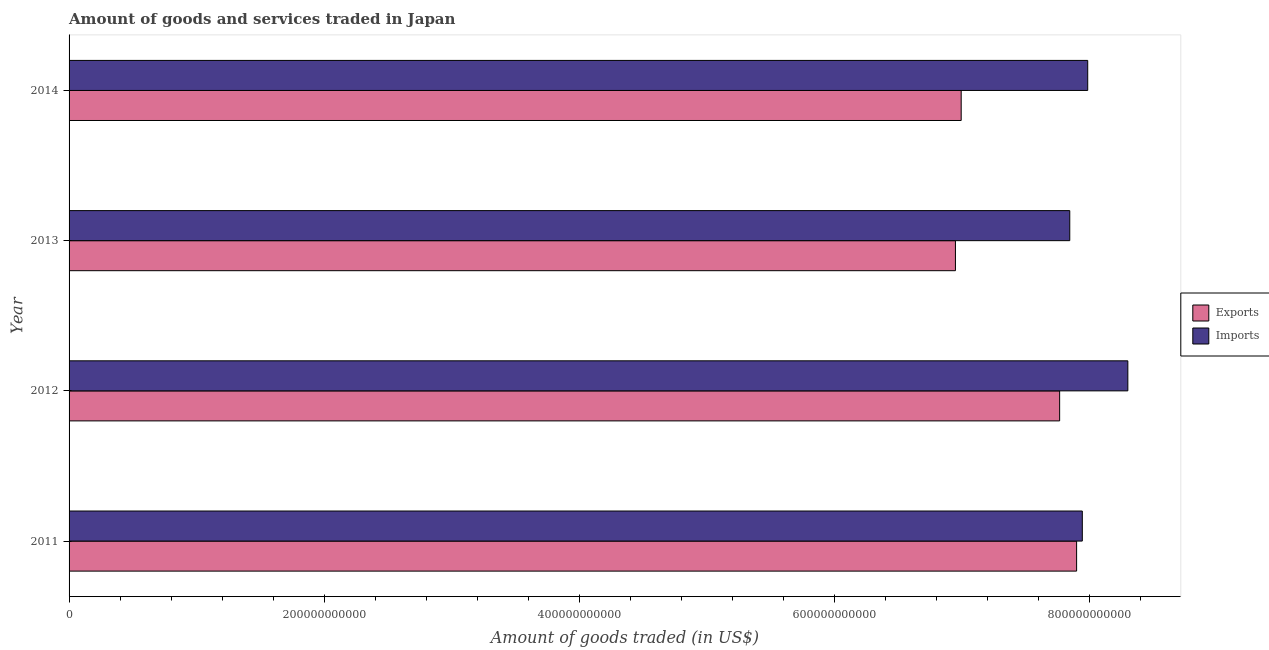How many different coloured bars are there?
Your answer should be compact. 2. How many groups of bars are there?
Offer a terse response. 4. Are the number of bars per tick equal to the number of legend labels?
Provide a short and direct response. Yes. How many bars are there on the 3rd tick from the top?
Make the answer very short. 2. How many bars are there on the 4th tick from the bottom?
Your answer should be very brief. 2. What is the label of the 4th group of bars from the top?
Keep it short and to the point. 2011. What is the amount of goods imported in 2012?
Offer a terse response. 8.30e+11. Across all years, what is the maximum amount of goods exported?
Your response must be concise. 7.90e+11. Across all years, what is the minimum amount of goods exported?
Your answer should be very brief. 6.95e+11. In which year was the amount of goods exported maximum?
Give a very brief answer. 2011. What is the total amount of goods imported in the graph?
Your answer should be very brief. 3.21e+12. What is the difference between the amount of goods exported in 2011 and that in 2013?
Your answer should be compact. 9.50e+1. What is the difference between the amount of goods imported in 2014 and the amount of goods exported in 2011?
Offer a very short reply. 8.70e+09. What is the average amount of goods imported per year?
Offer a terse response. 8.02e+11. In the year 2011, what is the difference between the amount of goods imported and amount of goods exported?
Give a very brief answer. 4.47e+09. What is the ratio of the amount of goods exported in 2011 to that in 2014?
Your response must be concise. 1.13. What is the difference between the highest and the second highest amount of goods imported?
Keep it short and to the point. 3.15e+1. What is the difference between the highest and the lowest amount of goods imported?
Your answer should be compact. 4.55e+1. What does the 2nd bar from the top in 2013 represents?
Your response must be concise. Exports. What does the 2nd bar from the bottom in 2013 represents?
Provide a succinct answer. Imports. Are all the bars in the graph horizontal?
Make the answer very short. Yes. What is the difference between two consecutive major ticks on the X-axis?
Make the answer very short. 2.00e+11. Does the graph contain any zero values?
Keep it short and to the point. No. How are the legend labels stacked?
Your answer should be compact. Vertical. What is the title of the graph?
Provide a short and direct response. Amount of goods and services traded in Japan. What is the label or title of the X-axis?
Provide a short and direct response. Amount of goods traded (in US$). What is the Amount of goods traded (in US$) of Exports in 2011?
Make the answer very short. 7.90e+11. What is the Amount of goods traded (in US$) in Imports in 2011?
Provide a short and direct response. 7.94e+11. What is the Amount of goods traded (in US$) of Exports in 2012?
Your answer should be compact. 7.77e+11. What is the Amount of goods traded (in US$) of Imports in 2012?
Your answer should be compact. 8.30e+11. What is the Amount of goods traded (in US$) in Exports in 2013?
Your response must be concise. 6.95e+11. What is the Amount of goods traded (in US$) of Imports in 2013?
Provide a short and direct response. 7.85e+11. What is the Amount of goods traded (in US$) in Exports in 2014?
Give a very brief answer. 6.99e+11. What is the Amount of goods traded (in US$) of Imports in 2014?
Give a very brief answer. 7.99e+11. Across all years, what is the maximum Amount of goods traded (in US$) of Exports?
Offer a very short reply. 7.90e+11. Across all years, what is the maximum Amount of goods traded (in US$) in Imports?
Provide a short and direct response. 8.30e+11. Across all years, what is the minimum Amount of goods traded (in US$) of Exports?
Your response must be concise. 6.95e+11. Across all years, what is the minimum Amount of goods traded (in US$) of Imports?
Offer a very short reply. 7.85e+11. What is the total Amount of goods traded (in US$) in Exports in the graph?
Provide a succinct answer. 2.96e+12. What is the total Amount of goods traded (in US$) of Imports in the graph?
Provide a short and direct response. 3.21e+12. What is the difference between the Amount of goods traded (in US$) in Exports in 2011 and that in 2012?
Your answer should be very brief. 1.33e+1. What is the difference between the Amount of goods traded (in US$) in Imports in 2011 and that in 2012?
Ensure brevity in your answer.  -3.57e+1. What is the difference between the Amount of goods traded (in US$) in Exports in 2011 and that in 2013?
Your answer should be very brief. 9.50e+1. What is the difference between the Amount of goods traded (in US$) of Imports in 2011 and that in 2013?
Make the answer very short. 9.84e+09. What is the difference between the Amount of goods traded (in US$) of Exports in 2011 and that in 2014?
Provide a short and direct response. 9.05e+1. What is the difference between the Amount of goods traded (in US$) in Imports in 2011 and that in 2014?
Ensure brevity in your answer.  -4.23e+09. What is the difference between the Amount of goods traded (in US$) in Exports in 2012 and that in 2013?
Keep it short and to the point. 8.17e+1. What is the difference between the Amount of goods traded (in US$) in Imports in 2012 and that in 2013?
Make the answer very short. 4.55e+1. What is the difference between the Amount of goods traded (in US$) in Exports in 2012 and that in 2014?
Provide a succinct answer. 7.72e+1. What is the difference between the Amount of goods traded (in US$) in Imports in 2012 and that in 2014?
Make the answer very short. 3.15e+1. What is the difference between the Amount of goods traded (in US$) of Exports in 2013 and that in 2014?
Your answer should be compact. -4.51e+09. What is the difference between the Amount of goods traded (in US$) in Imports in 2013 and that in 2014?
Provide a succinct answer. -1.41e+1. What is the difference between the Amount of goods traded (in US$) in Exports in 2011 and the Amount of goods traded (in US$) in Imports in 2012?
Your answer should be very brief. -4.02e+1. What is the difference between the Amount of goods traded (in US$) in Exports in 2011 and the Amount of goods traded (in US$) in Imports in 2013?
Keep it short and to the point. 5.36e+09. What is the difference between the Amount of goods traded (in US$) of Exports in 2011 and the Amount of goods traded (in US$) of Imports in 2014?
Provide a succinct answer. -8.70e+09. What is the difference between the Amount of goods traded (in US$) in Exports in 2012 and the Amount of goods traded (in US$) in Imports in 2013?
Ensure brevity in your answer.  -7.95e+09. What is the difference between the Amount of goods traded (in US$) of Exports in 2012 and the Amount of goods traded (in US$) of Imports in 2014?
Keep it short and to the point. -2.20e+1. What is the difference between the Amount of goods traded (in US$) in Exports in 2013 and the Amount of goods traded (in US$) in Imports in 2014?
Give a very brief answer. -1.04e+11. What is the average Amount of goods traded (in US$) of Exports per year?
Provide a short and direct response. 7.40e+11. What is the average Amount of goods traded (in US$) in Imports per year?
Your response must be concise. 8.02e+11. In the year 2011, what is the difference between the Amount of goods traded (in US$) of Exports and Amount of goods traded (in US$) of Imports?
Your response must be concise. -4.47e+09. In the year 2012, what is the difference between the Amount of goods traded (in US$) in Exports and Amount of goods traded (in US$) in Imports?
Make the answer very short. -5.35e+1. In the year 2013, what is the difference between the Amount of goods traded (in US$) of Exports and Amount of goods traded (in US$) of Imports?
Provide a succinct answer. -8.96e+1. In the year 2014, what is the difference between the Amount of goods traded (in US$) of Exports and Amount of goods traded (in US$) of Imports?
Give a very brief answer. -9.92e+1. What is the ratio of the Amount of goods traded (in US$) of Exports in 2011 to that in 2012?
Your response must be concise. 1.02. What is the ratio of the Amount of goods traded (in US$) of Imports in 2011 to that in 2012?
Offer a terse response. 0.96. What is the ratio of the Amount of goods traded (in US$) of Exports in 2011 to that in 2013?
Ensure brevity in your answer.  1.14. What is the ratio of the Amount of goods traded (in US$) in Imports in 2011 to that in 2013?
Your answer should be very brief. 1.01. What is the ratio of the Amount of goods traded (in US$) in Exports in 2011 to that in 2014?
Offer a very short reply. 1.13. What is the ratio of the Amount of goods traded (in US$) of Exports in 2012 to that in 2013?
Your answer should be very brief. 1.12. What is the ratio of the Amount of goods traded (in US$) of Imports in 2012 to that in 2013?
Your response must be concise. 1.06. What is the ratio of the Amount of goods traded (in US$) in Exports in 2012 to that in 2014?
Offer a very short reply. 1.11. What is the ratio of the Amount of goods traded (in US$) of Imports in 2012 to that in 2014?
Your answer should be compact. 1.04. What is the ratio of the Amount of goods traded (in US$) in Exports in 2013 to that in 2014?
Your response must be concise. 0.99. What is the ratio of the Amount of goods traded (in US$) of Imports in 2013 to that in 2014?
Provide a short and direct response. 0.98. What is the difference between the highest and the second highest Amount of goods traded (in US$) of Exports?
Ensure brevity in your answer.  1.33e+1. What is the difference between the highest and the second highest Amount of goods traded (in US$) in Imports?
Offer a terse response. 3.15e+1. What is the difference between the highest and the lowest Amount of goods traded (in US$) in Exports?
Provide a succinct answer. 9.50e+1. What is the difference between the highest and the lowest Amount of goods traded (in US$) of Imports?
Keep it short and to the point. 4.55e+1. 